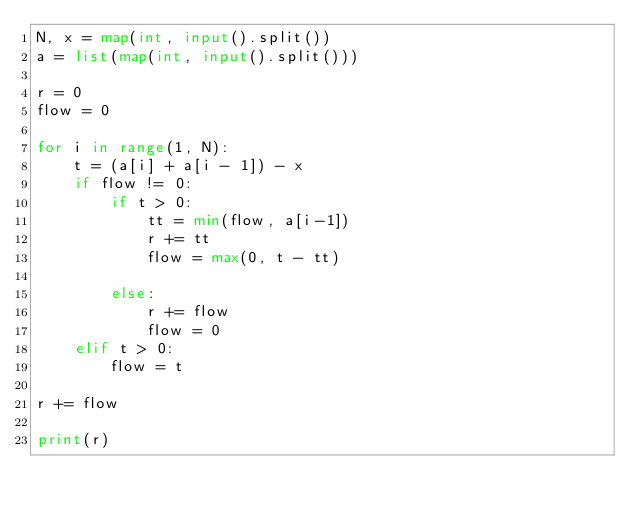Convert code to text. <code><loc_0><loc_0><loc_500><loc_500><_Python_>N, x = map(int, input().split())
a = list(map(int, input().split()))

r = 0
flow = 0

for i in range(1, N):
    t = (a[i] + a[i - 1]) - x
    if flow != 0:
        if t > 0:
            tt = min(flow, a[i-1])
            r += tt
            flow = max(0, t - tt)

        else:
            r += flow
            flow = 0
    elif t > 0:
        flow = t

r += flow

print(r)</code> 